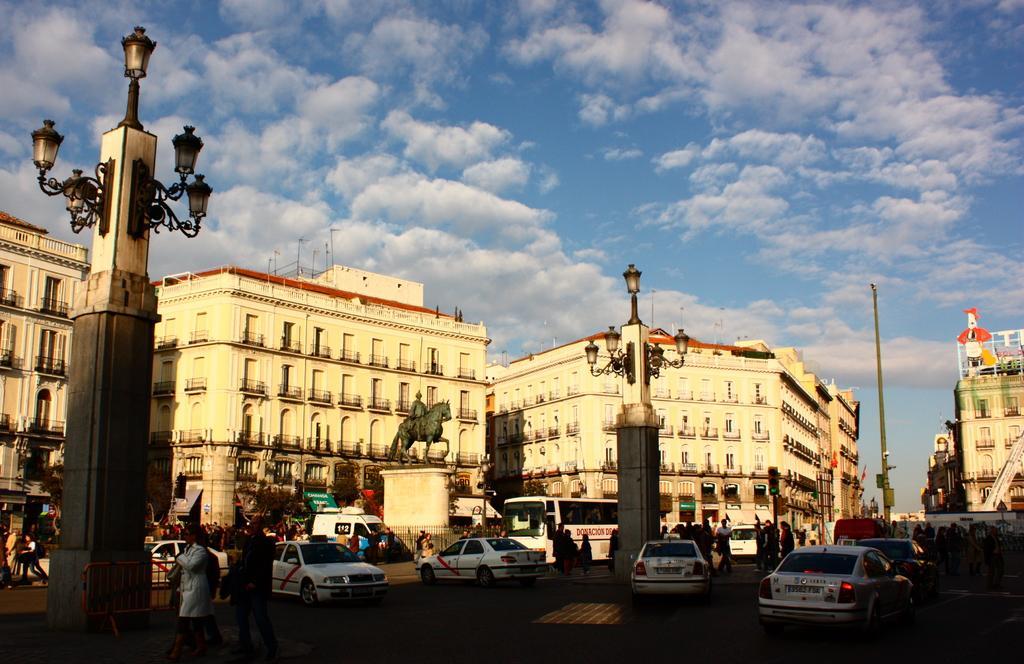Could you give a brief overview of what you see in this image? In this image we can see vehicles and people on the road. In the background, we can see buildings, pole, towers, lights, statue, boards and trees. At the top of the image, we can see the sky with clouds. 